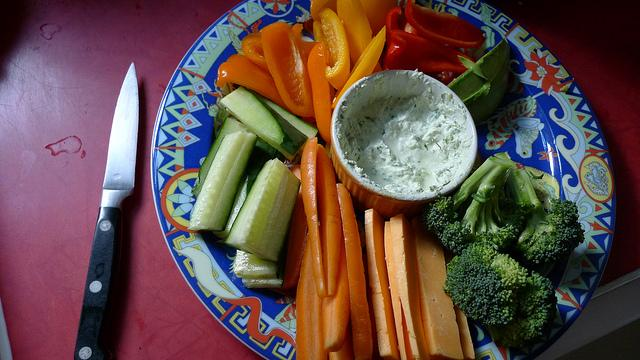What is the white substance in the middle of the plate used for? dipping 